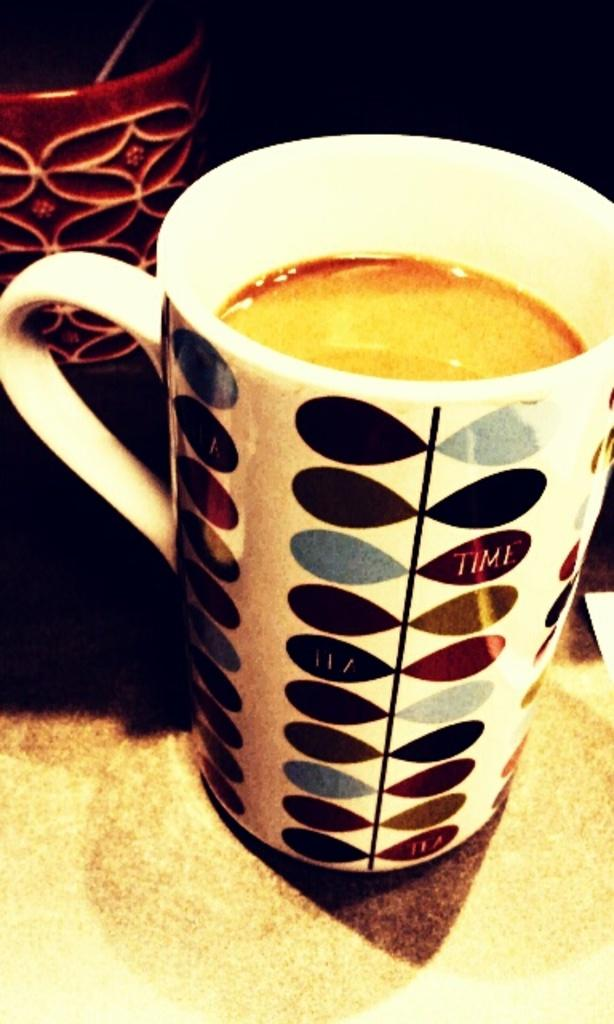What objects are visible in the image? There are cups in the image. What is inside the cups? There is a drink in the cups. Can you describe the background of the image? The background of the image is dark. What is the caption of the image? There is no caption present in the image. How does the fifth cup affect the overall composition of the image? There is no mention of a fifth cup in the provided facts, so it cannot be determined how it would affect the composition of the image. 